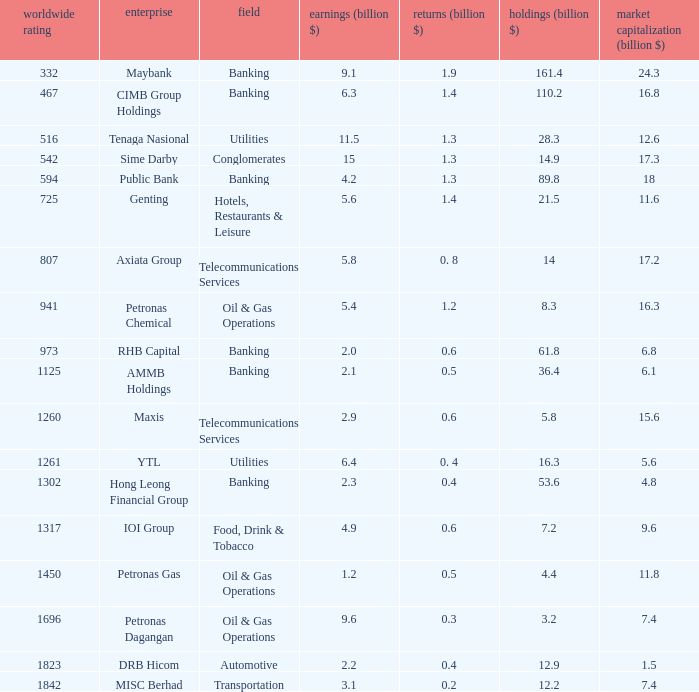Name the world rank for market value 17.2 807.0. 